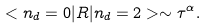<formula> <loc_0><loc_0><loc_500><loc_500>< n _ { d } = 0 | R | n _ { d } = 2 > \sim \tau ^ { \alpha } .</formula> 